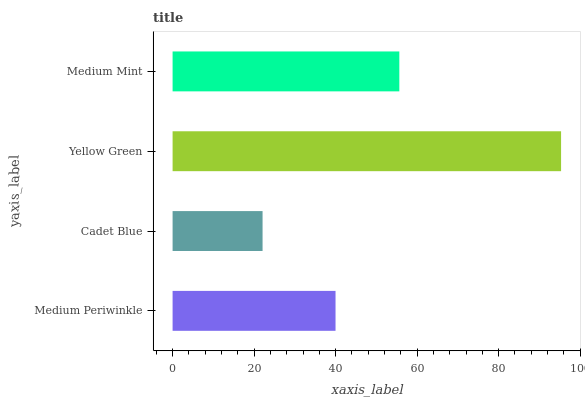Is Cadet Blue the minimum?
Answer yes or no. Yes. Is Yellow Green the maximum?
Answer yes or no. Yes. Is Yellow Green the minimum?
Answer yes or no. No. Is Cadet Blue the maximum?
Answer yes or no. No. Is Yellow Green greater than Cadet Blue?
Answer yes or no. Yes. Is Cadet Blue less than Yellow Green?
Answer yes or no. Yes. Is Cadet Blue greater than Yellow Green?
Answer yes or no. No. Is Yellow Green less than Cadet Blue?
Answer yes or no. No. Is Medium Mint the high median?
Answer yes or no. Yes. Is Medium Periwinkle the low median?
Answer yes or no. Yes. Is Medium Periwinkle the high median?
Answer yes or no. No. Is Cadet Blue the low median?
Answer yes or no. No. 